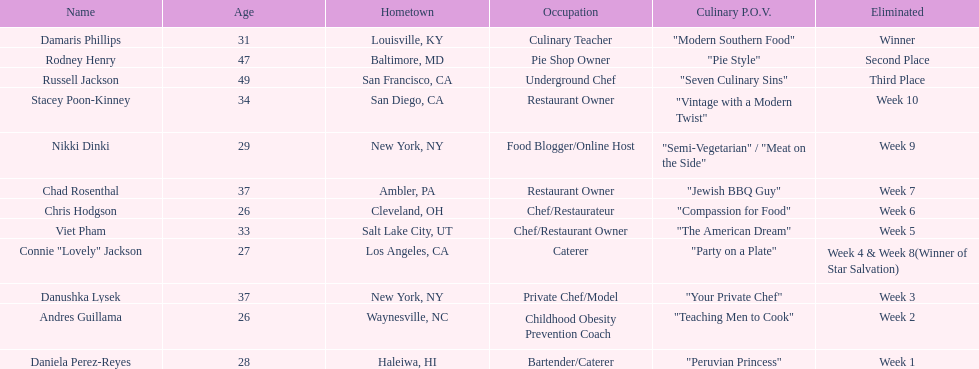Who faced elimination first, nikki dinki or viet pham? Viet Pham. 